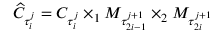Convert formula to latex. <formula><loc_0><loc_0><loc_500><loc_500>\widehat { C } _ { \tau _ { i } ^ { j } } = C _ { \tau _ { i } ^ { j } } \times _ { 1 } M _ { \tau _ { 2 i - 1 } ^ { j + 1 } } \times _ { 2 } M _ { \tau _ { 2 i } ^ { j + 1 } }</formula> 